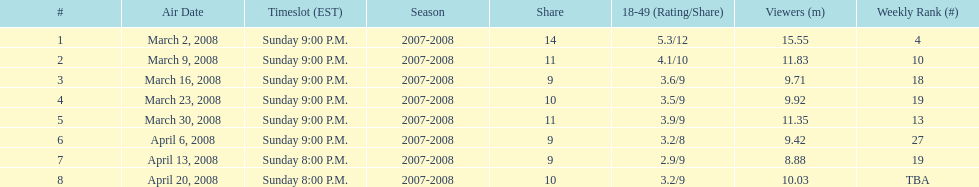For the first 6 episodes, what was the show's time slot? Sunday 9:00 P.M. 